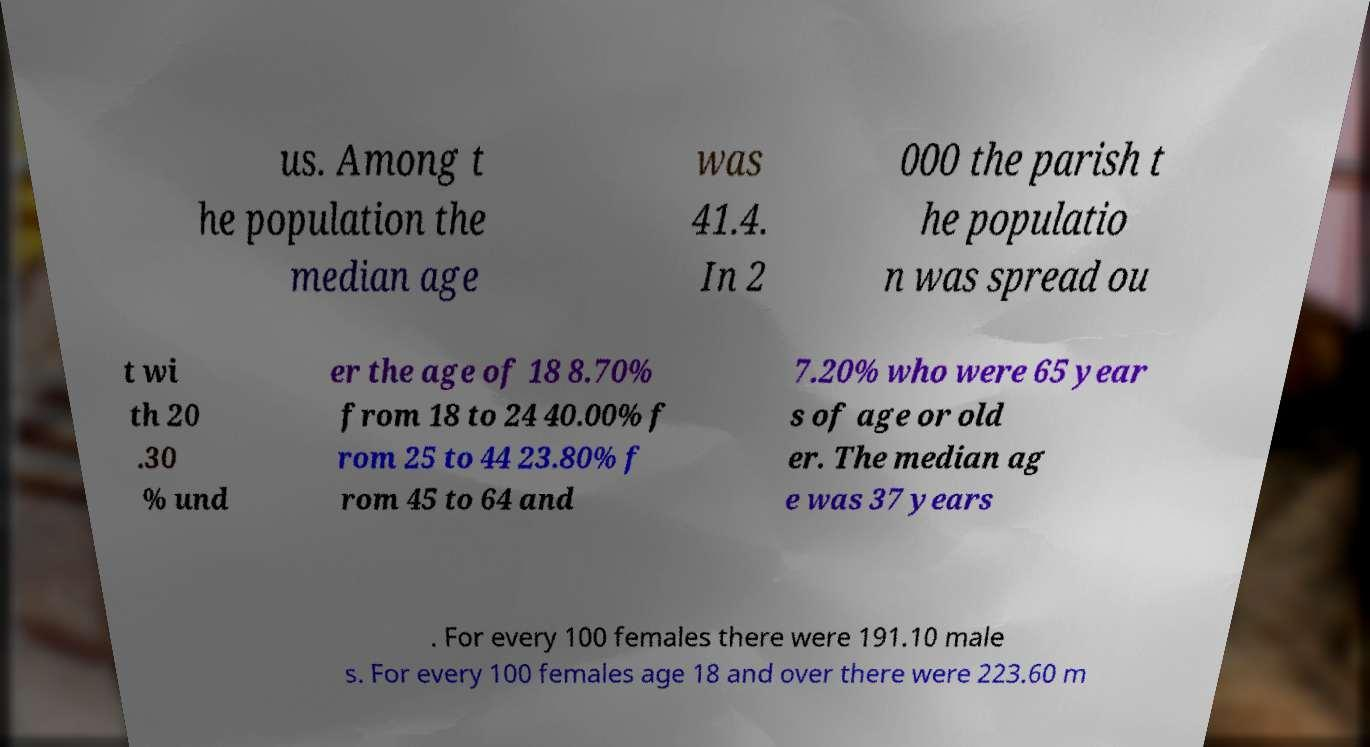There's text embedded in this image that I need extracted. Can you transcribe it verbatim? us. Among t he population the median age was 41.4. In 2 000 the parish t he populatio n was spread ou t wi th 20 .30 % und er the age of 18 8.70% from 18 to 24 40.00% f rom 25 to 44 23.80% f rom 45 to 64 and 7.20% who were 65 year s of age or old er. The median ag e was 37 years . For every 100 females there were 191.10 male s. For every 100 females age 18 and over there were 223.60 m 